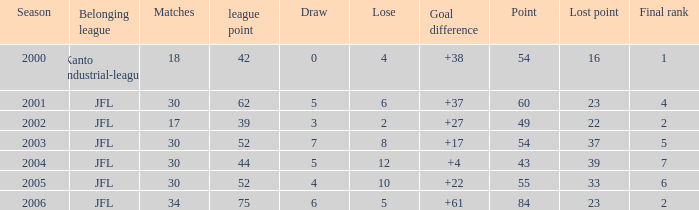I want the average lose for lost point more than 16 and goal difference less than 37 and point less than 43 None. 